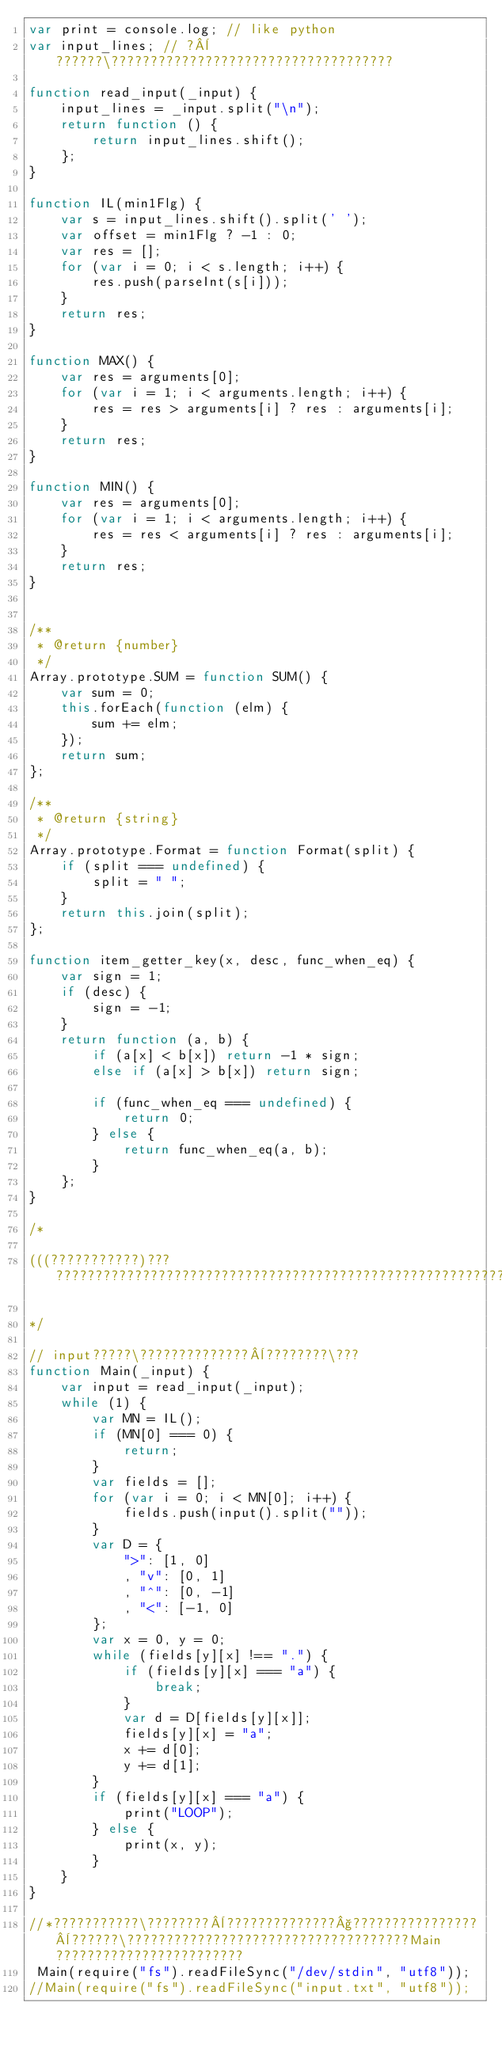Convert code to text. <code><loc_0><loc_0><loc_500><loc_500><_JavaScript_>var print = console.log; // like python
var input_lines; // ?¨??????\????????????????????????????????????

function read_input(_input) {
    input_lines = _input.split("\n");
    return function () {
        return input_lines.shift();
    };
}

function IL(min1Flg) {
    var s = input_lines.shift().split(' ');
    var offset = min1Flg ? -1 : 0;
    var res = [];
    for (var i = 0; i < s.length; i++) {
        res.push(parseInt(s[i]));
    }
    return res;
}

function MAX() {
    var res = arguments[0];
    for (var i = 1; i < arguments.length; i++) {
        res = res > arguments[i] ? res : arguments[i];
    }
    return res;
}

function MIN() {
    var res = arguments[0];
    for (var i = 1; i < arguments.length; i++) {
        res = res < arguments[i] ? res : arguments[i];
    }
    return res;
}


/**
 * @return {number}
 */
Array.prototype.SUM = function SUM() {
    var sum = 0;
    this.forEach(function (elm) {
        sum += elm;
    });
    return sum;
};

/**
 * @return {string}
 */
Array.prototype.Format = function Format(split) {
    if (split === undefined) {
        split = " ";
    }
    return this.join(split);
};

function item_getter_key(x, desc, func_when_eq) {
    var sign = 1;
    if (desc) {
        sign = -1;
    }
    return function (a, b) {
        if (a[x] < b[x]) return -1 * sign;
        else if (a[x] > b[x]) return sign;

        if (func_when_eq === undefined) {
            return 0;
        } else {
            return func_when_eq(a, b);
        }
    };
}

/*

(((???????????)??? ????????????????????????????????????????????????????????????????????????????????????????????????????????????????????????????????????????????????

*/

// input?????\??????????????¨????????\???
function Main(_input) {
    var input = read_input(_input);
    while (1) {
        var MN = IL();
        if (MN[0] === 0) {
            return;
        }
        var fields = [];
        for (var i = 0; i < MN[0]; i++) {
            fields.push(input().split(""));
        }
        var D = {
            ">": [1, 0]
            , "v": [0, 1]
            , "^": [0, -1]
            , "<": [-1, 0]
        };
        var x = 0, y = 0;
        while (fields[y][x] !== ".") {
            if (fields[y][x] === "a") {
                break;
            }
            var d = D[fields[y][x]];
            fields[y][x] = "a";
            x += d[0];
            y += d[1];
        }
        if (fields[y][x] === "a") {
            print("LOOP");
        } else {
            print(x, y);
        }
    }
}

//*???????????\????????¨??????????????§????????????????¨??????\????????????????????????????????????Main????????????????????????
 Main(require("fs").readFileSync("/dev/stdin", "utf8"));
//Main(require("fs").readFileSync("input.txt", "utf8"));</code> 